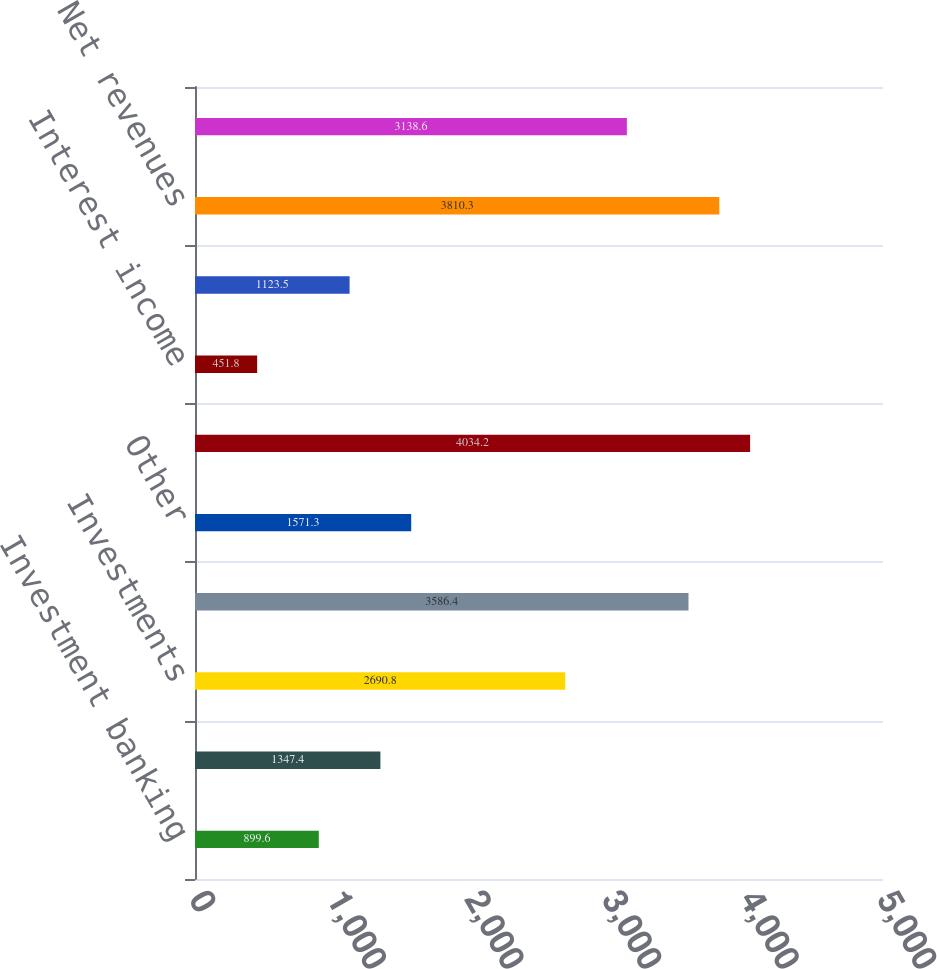Convert chart to OTSL. <chart><loc_0><loc_0><loc_500><loc_500><bar_chart><fcel>Investment banking<fcel>Trading<fcel>Investments<fcel>Asset management distribution<fcel>Other<fcel>Total non-interest revenues<fcel>Interest income<fcel>Interest expense<fcel>Net revenues<fcel>Compensation and benefits<nl><fcel>899.6<fcel>1347.4<fcel>2690.8<fcel>3586.4<fcel>1571.3<fcel>4034.2<fcel>451.8<fcel>1123.5<fcel>3810.3<fcel>3138.6<nl></chart> 